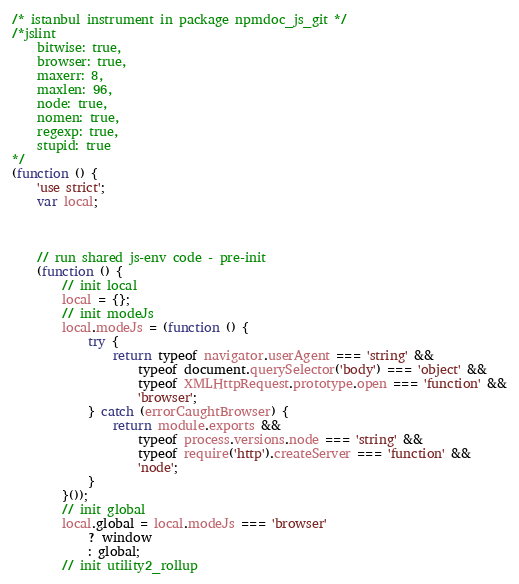<code> <loc_0><loc_0><loc_500><loc_500><_JavaScript_>/* istanbul instrument in package npmdoc_js_git */
/*jslint
    bitwise: true,
    browser: true,
    maxerr: 8,
    maxlen: 96,
    node: true,
    nomen: true,
    regexp: true,
    stupid: true
*/
(function () {
    'use strict';
    var local;



    // run shared js-env code - pre-init
    (function () {
        // init local
        local = {};
        // init modeJs
        local.modeJs = (function () {
            try {
                return typeof navigator.userAgent === 'string' &&
                    typeof document.querySelector('body') === 'object' &&
                    typeof XMLHttpRequest.prototype.open === 'function' &&
                    'browser';
            } catch (errorCaughtBrowser) {
                return module.exports &&
                    typeof process.versions.node === 'string' &&
                    typeof require('http').createServer === 'function' &&
                    'node';
            }
        }());
        // init global
        local.global = local.modeJs === 'browser'
            ? window
            : global;
        // init utility2_rollup</code> 